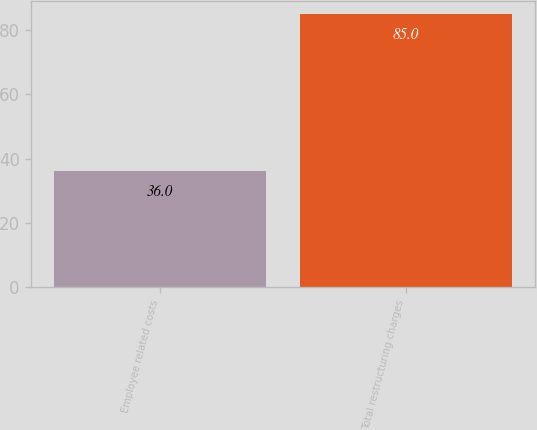Convert chart. <chart><loc_0><loc_0><loc_500><loc_500><bar_chart><fcel>Employee related costs<fcel>Total restructuring charges<nl><fcel>36<fcel>85<nl></chart> 